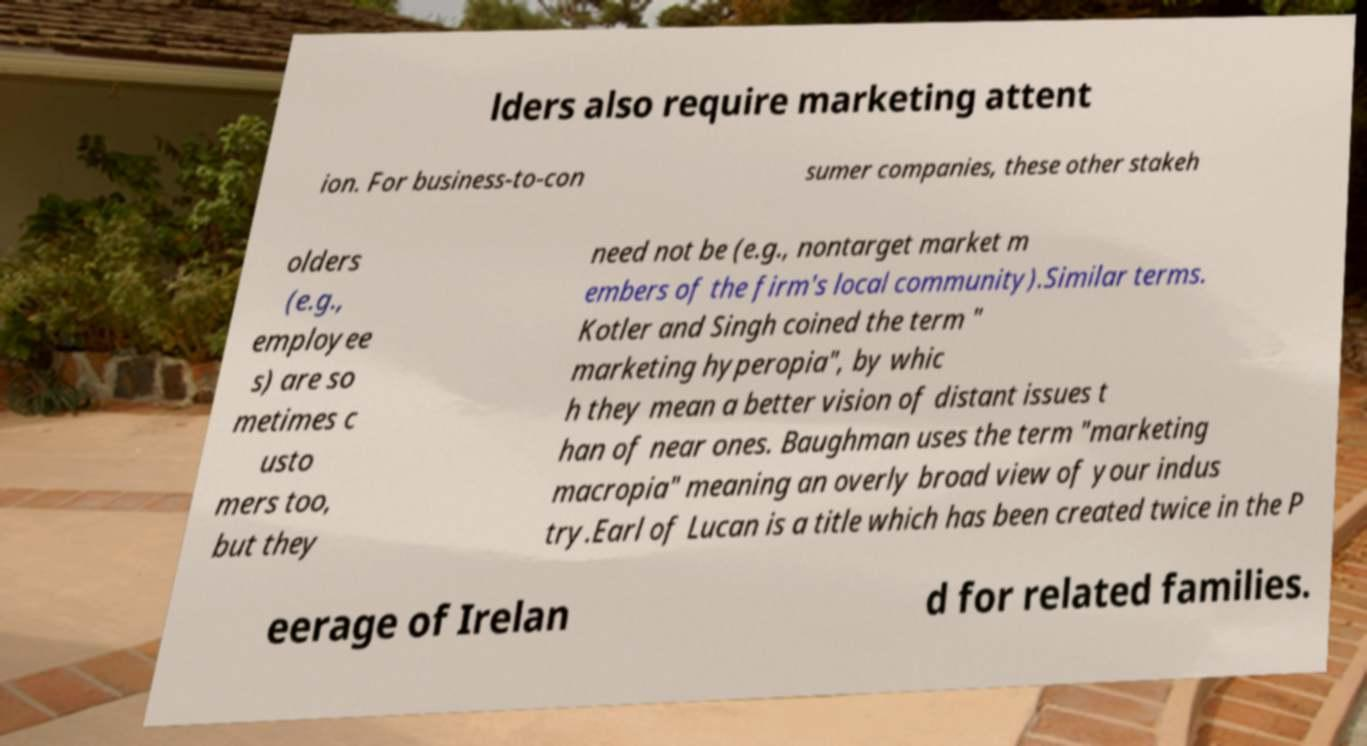Please read and relay the text visible in this image. What does it say? lders also require marketing attent ion. For business-to-con sumer companies, these other stakeh olders (e.g., employee s) are so metimes c usto mers too, but they need not be (e.g., nontarget market m embers of the firm's local community).Similar terms. Kotler and Singh coined the term " marketing hyperopia", by whic h they mean a better vision of distant issues t han of near ones. Baughman uses the term "marketing macropia" meaning an overly broad view of your indus try.Earl of Lucan is a title which has been created twice in the P eerage of Irelan d for related families. 